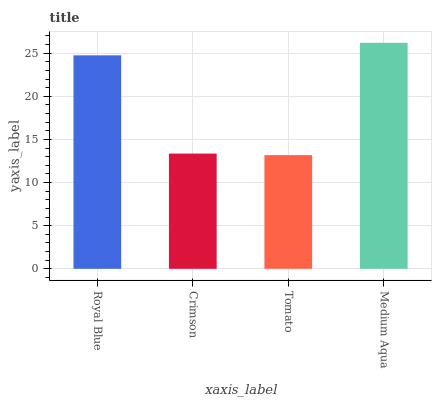Is Tomato the minimum?
Answer yes or no. Yes. Is Medium Aqua the maximum?
Answer yes or no. Yes. Is Crimson the minimum?
Answer yes or no. No. Is Crimson the maximum?
Answer yes or no. No. Is Royal Blue greater than Crimson?
Answer yes or no. Yes. Is Crimson less than Royal Blue?
Answer yes or no. Yes. Is Crimson greater than Royal Blue?
Answer yes or no. No. Is Royal Blue less than Crimson?
Answer yes or no. No. Is Royal Blue the high median?
Answer yes or no. Yes. Is Crimson the low median?
Answer yes or no. Yes. Is Medium Aqua the high median?
Answer yes or no. No. Is Tomato the low median?
Answer yes or no. No. 